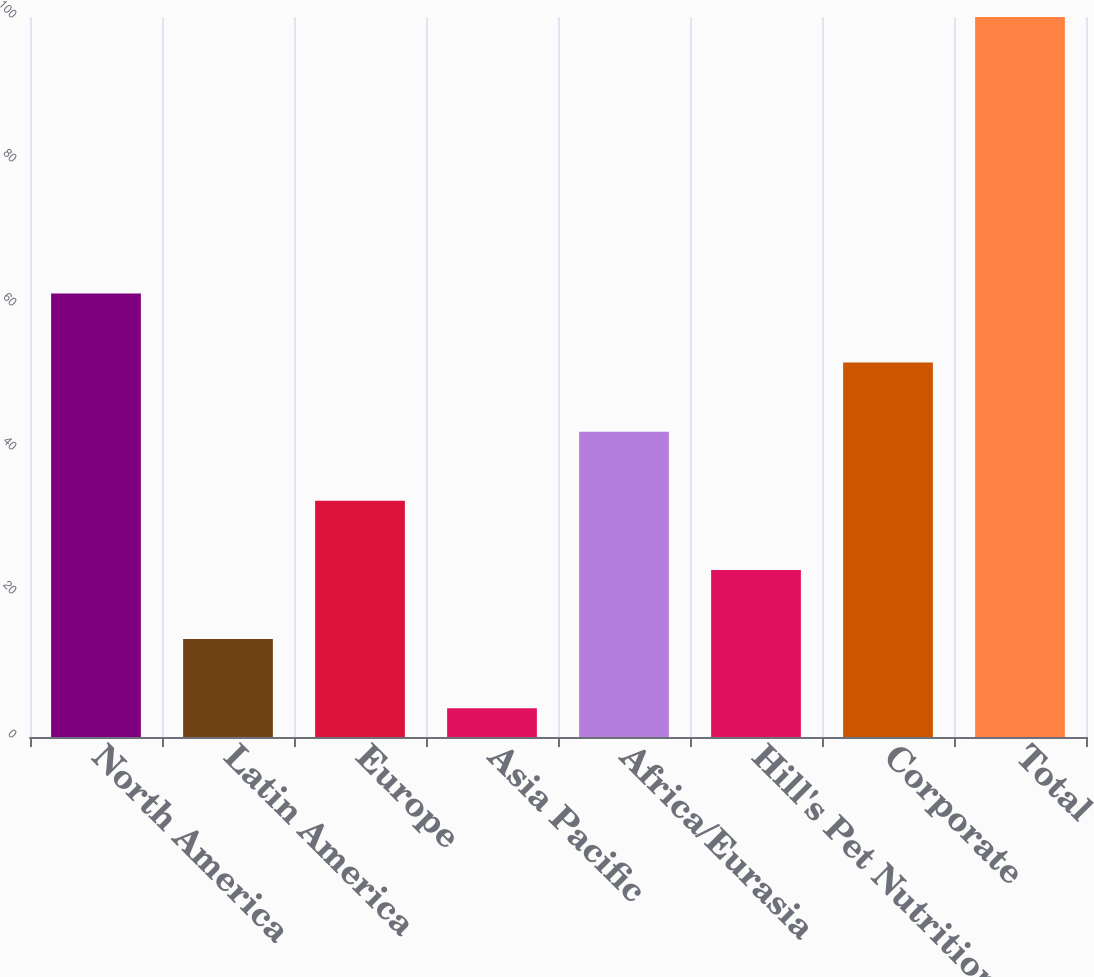Convert chart. <chart><loc_0><loc_0><loc_500><loc_500><bar_chart><fcel>North America<fcel>Latin America<fcel>Europe<fcel>Asia Pacific<fcel>Africa/Eurasia<fcel>Hill's Pet Nutrition<fcel>Corporate<fcel>Total<nl><fcel>61.6<fcel>13.6<fcel>32.8<fcel>4<fcel>42.4<fcel>23.2<fcel>52<fcel>100<nl></chart> 